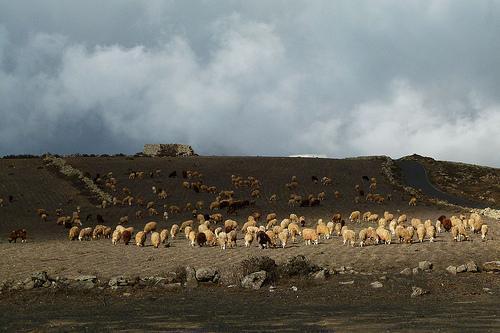How many white buffalos are in the photo?
Give a very brief answer. 0. 